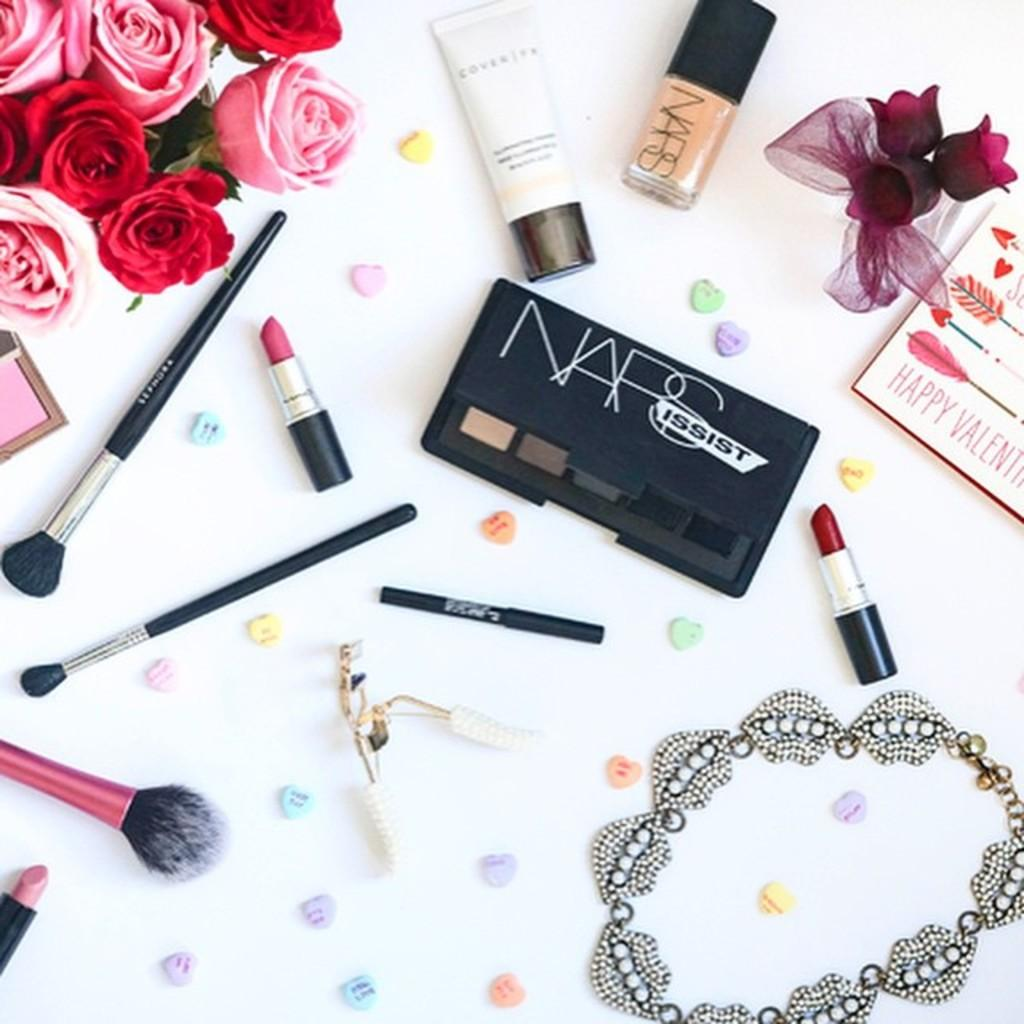<image>
Create a compact narrative representing the image presented. A collection of makeup is next to a Valentine's Day card. 